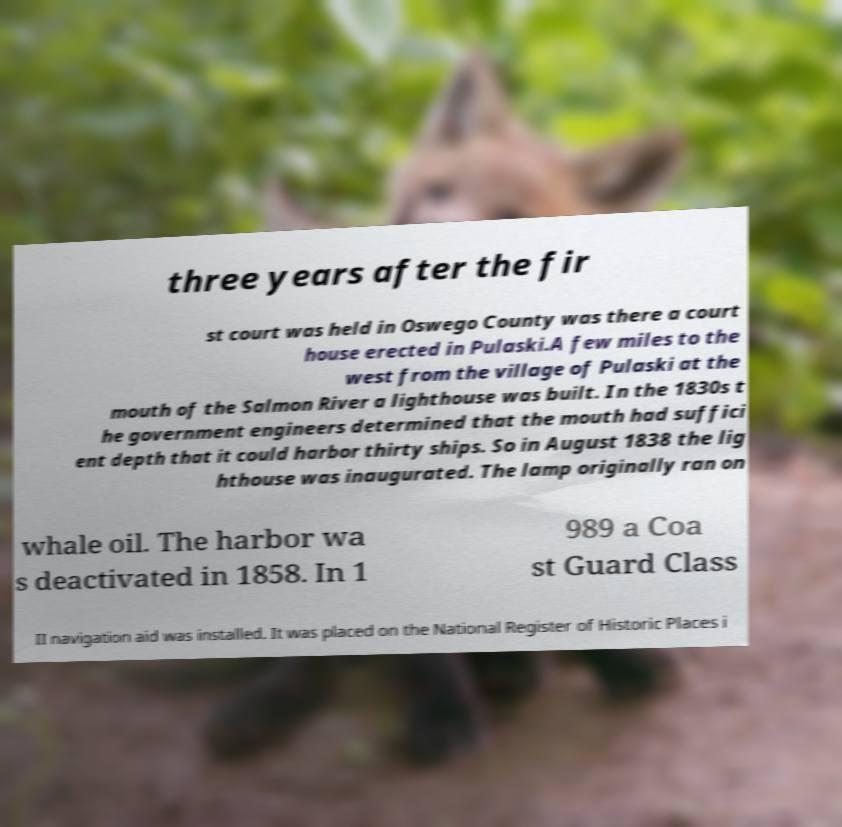Could you assist in decoding the text presented in this image and type it out clearly? three years after the fir st court was held in Oswego County was there a court house erected in Pulaski.A few miles to the west from the village of Pulaski at the mouth of the Salmon River a lighthouse was built. In the 1830s t he government engineers determined that the mouth had suffici ent depth that it could harbor thirty ships. So in August 1838 the lig hthouse was inaugurated. The lamp originally ran on whale oil. The harbor wa s deactivated in 1858. In 1 989 a Coa st Guard Class II navigation aid was installed. It was placed on the National Register of Historic Places i 